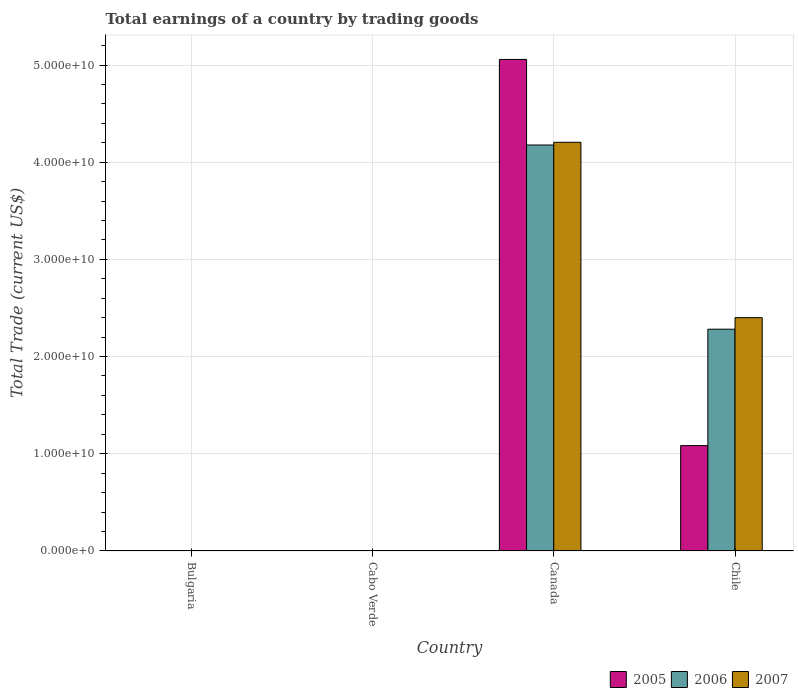How many different coloured bars are there?
Provide a succinct answer. 3. Are the number of bars on each tick of the X-axis equal?
Provide a succinct answer. No. What is the total earnings in 2007 in Cabo Verde?
Provide a succinct answer. 0. Across all countries, what is the maximum total earnings in 2005?
Provide a short and direct response. 5.06e+1. What is the total total earnings in 2005 in the graph?
Your answer should be very brief. 6.14e+1. What is the difference between the total earnings in 2005 in Canada and that in Chile?
Give a very brief answer. 3.97e+1. What is the difference between the total earnings in 2006 in Cabo Verde and the total earnings in 2005 in Canada?
Your answer should be compact. -5.06e+1. What is the average total earnings in 2006 per country?
Provide a succinct answer. 1.61e+1. What is the difference between the total earnings of/in 2007 and total earnings of/in 2005 in Canada?
Your response must be concise. -8.52e+09. Is the total earnings in 2007 in Canada less than that in Chile?
Offer a terse response. No. What is the difference between the highest and the lowest total earnings in 2007?
Give a very brief answer. 4.20e+1. In how many countries, is the total earnings in 2006 greater than the average total earnings in 2006 taken over all countries?
Your response must be concise. 2. How many bars are there?
Your answer should be compact. 6. How many countries are there in the graph?
Provide a short and direct response. 4. Does the graph contain any zero values?
Provide a short and direct response. Yes. Does the graph contain grids?
Ensure brevity in your answer.  Yes. Where does the legend appear in the graph?
Your answer should be compact. Bottom right. How many legend labels are there?
Keep it short and to the point. 3. What is the title of the graph?
Provide a short and direct response. Total earnings of a country by trading goods. What is the label or title of the Y-axis?
Provide a succinct answer. Total Trade (current US$). What is the Total Trade (current US$) of 2007 in Bulgaria?
Provide a succinct answer. 0. What is the Total Trade (current US$) of 2005 in Cabo Verde?
Your answer should be compact. 0. What is the Total Trade (current US$) of 2005 in Canada?
Keep it short and to the point. 5.06e+1. What is the Total Trade (current US$) of 2006 in Canada?
Give a very brief answer. 4.18e+1. What is the Total Trade (current US$) of 2007 in Canada?
Your answer should be compact. 4.20e+1. What is the Total Trade (current US$) in 2005 in Chile?
Ensure brevity in your answer.  1.08e+1. What is the Total Trade (current US$) in 2006 in Chile?
Keep it short and to the point. 2.28e+1. What is the Total Trade (current US$) of 2007 in Chile?
Offer a terse response. 2.40e+1. Across all countries, what is the maximum Total Trade (current US$) in 2005?
Provide a short and direct response. 5.06e+1. Across all countries, what is the maximum Total Trade (current US$) of 2006?
Offer a terse response. 4.18e+1. Across all countries, what is the maximum Total Trade (current US$) of 2007?
Your response must be concise. 4.20e+1. Across all countries, what is the minimum Total Trade (current US$) of 2006?
Your answer should be compact. 0. Across all countries, what is the minimum Total Trade (current US$) in 2007?
Offer a terse response. 0. What is the total Total Trade (current US$) in 2005 in the graph?
Make the answer very short. 6.14e+1. What is the total Total Trade (current US$) of 2006 in the graph?
Your answer should be compact. 6.46e+1. What is the total Total Trade (current US$) in 2007 in the graph?
Ensure brevity in your answer.  6.61e+1. What is the difference between the Total Trade (current US$) in 2005 in Canada and that in Chile?
Offer a terse response. 3.97e+1. What is the difference between the Total Trade (current US$) in 2006 in Canada and that in Chile?
Provide a short and direct response. 1.90e+1. What is the difference between the Total Trade (current US$) of 2007 in Canada and that in Chile?
Give a very brief answer. 1.80e+1. What is the difference between the Total Trade (current US$) in 2005 in Canada and the Total Trade (current US$) in 2006 in Chile?
Give a very brief answer. 2.78e+1. What is the difference between the Total Trade (current US$) of 2005 in Canada and the Total Trade (current US$) of 2007 in Chile?
Your response must be concise. 2.66e+1. What is the difference between the Total Trade (current US$) of 2006 in Canada and the Total Trade (current US$) of 2007 in Chile?
Offer a terse response. 1.78e+1. What is the average Total Trade (current US$) of 2005 per country?
Your response must be concise. 1.54e+1. What is the average Total Trade (current US$) in 2006 per country?
Offer a terse response. 1.61e+1. What is the average Total Trade (current US$) in 2007 per country?
Give a very brief answer. 1.65e+1. What is the difference between the Total Trade (current US$) in 2005 and Total Trade (current US$) in 2006 in Canada?
Your response must be concise. 8.80e+09. What is the difference between the Total Trade (current US$) in 2005 and Total Trade (current US$) in 2007 in Canada?
Provide a succinct answer. 8.52e+09. What is the difference between the Total Trade (current US$) of 2006 and Total Trade (current US$) of 2007 in Canada?
Your answer should be very brief. -2.80e+08. What is the difference between the Total Trade (current US$) of 2005 and Total Trade (current US$) of 2006 in Chile?
Ensure brevity in your answer.  -1.20e+1. What is the difference between the Total Trade (current US$) in 2005 and Total Trade (current US$) in 2007 in Chile?
Your answer should be compact. -1.32e+1. What is the difference between the Total Trade (current US$) of 2006 and Total Trade (current US$) of 2007 in Chile?
Provide a short and direct response. -1.19e+09. What is the ratio of the Total Trade (current US$) in 2005 in Canada to that in Chile?
Keep it short and to the point. 4.67. What is the ratio of the Total Trade (current US$) in 2006 in Canada to that in Chile?
Your answer should be very brief. 1.83. What is the ratio of the Total Trade (current US$) of 2007 in Canada to that in Chile?
Your response must be concise. 1.75. What is the difference between the highest and the lowest Total Trade (current US$) of 2005?
Provide a succinct answer. 5.06e+1. What is the difference between the highest and the lowest Total Trade (current US$) in 2006?
Offer a terse response. 4.18e+1. What is the difference between the highest and the lowest Total Trade (current US$) of 2007?
Your answer should be very brief. 4.20e+1. 